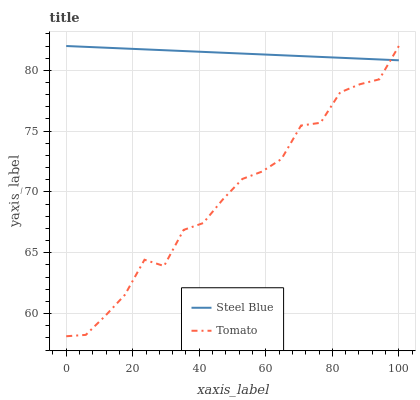Does Tomato have the minimum area under the curve?
Answer yes or no. Yes. Does Steel Blue have the maximum area under the curve?
Answer yes or no. Yes. Does Steel Blue have the minimum area under the curve?
Answer yes or no. No. Is Steel Blue the smoothest?
Answer yes or no. Yes. Is Tomato the roughest?
Answer yes or no. Yes. Is Steel Blue the roughest?
Answer yes or no. No. Does Tomato have the lowest value?
Answer yes or no. Yes. Does Steel Blue have the lowest value?
Answer yes or no. No. Does Steel Blue have the highest value?
Answer yes or no. Yes. Does Tomato intersect Steel Blue?
Answer yes or no. Yes. Is Tomato less than Steel Blue?
Answer yes or no. No. Is Tomato greater than Steel Blue?
Answer yes or no. No. 